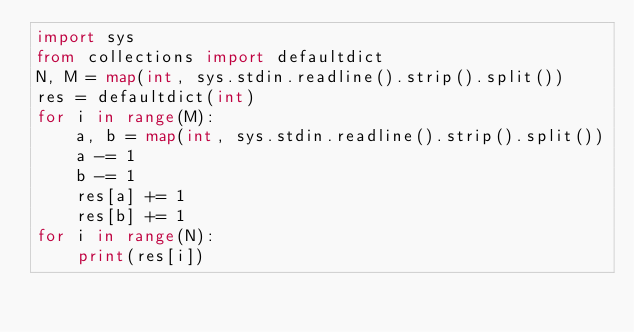<code> <loc_0><loc_0><loc_500><loc_500><_Python_>import sys
from collections import defaultdict
N, M = map(int, sys.stdin.readline().strip().split())
res = defaultdict(int)
for i in range(M):
    a, b = map(int, sys.stdin.readline().strip().split())
    a -= 1
    b -= 1
    res[a] += 1
    res[b] += 1
for i in range(N):
    print(res[i])

</code> 